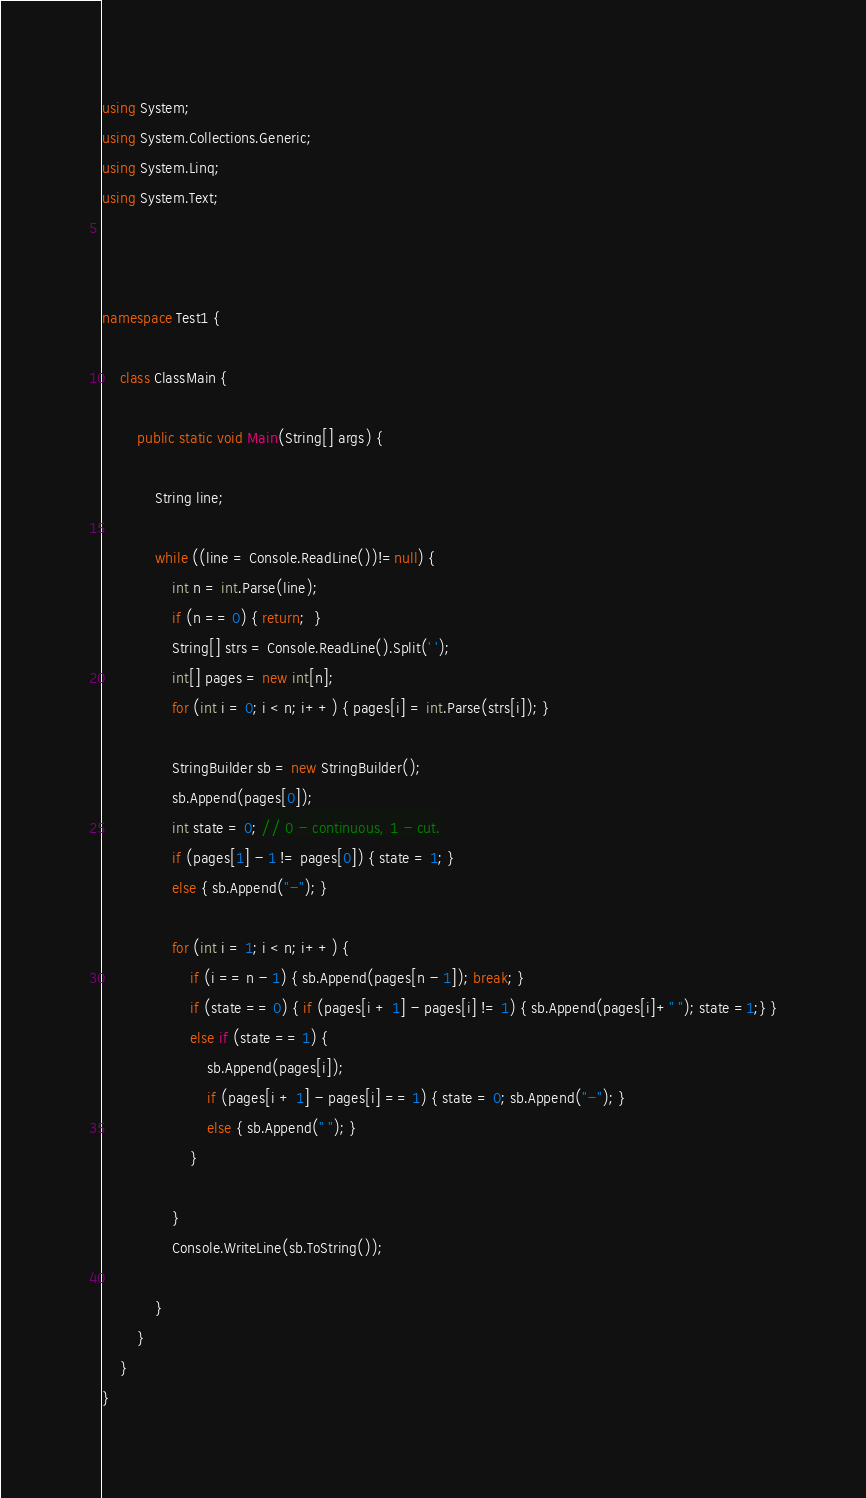Convert code to text. <code><loc_0><loc_0><loc_500><loc_500><_C#_>using System;
using System.Collections.Generic;
using System.Linq;
using System.Text;



namespace Test1 {

    class ClassMain {

        public static void Main(String[] args) {

            String line;
                
            while ((line = Console.ReadLine())!=null) {
                int n = int.Parse(line);
                if (n == 0) { return;  }
                String[] strs = Console.ReadLine().Split(' ');
                int[] pages = new int[n];
                for (int i = 0; i < n; i++) { pages[i] = int.Parse(strs[i]); }
                
                StringBuilder sb = new StringBuilder();
                sb.Append(pages[0]);
                int state = 0; // 0 - continuous, 1 - cut.
                if (pages[1] - 1 != pages[0]) { state = 1; }
                else { sb.Append("-"); }
 
                for (int i = 1; i < n; i++) {
                    if (i == n - 1) { sb.Append(pages[n - 1]); break; }
                    if (state == 0) { if (pages[i + 1] - pages[i] != 1) { sb.Append(pages[i]+" "); state =1;} }
                    else if (state == 1) { 
                        sb.Append(pages[i]);
                        if (pages[i + 1] - pages[i] == 1) { state = 0; sb.Append("-"); }
                        else { sb.Append(" "); }
                    }
                
                }
                Console.WriteLine(sb.ToString());

            }
        }
    }
}</code> 